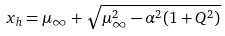<formula> <loc_0><loc_0><loc_500><loc_500>x _ { h } = \mu _ { \infty } + \sqrt { \mu _ { \infty } ^ { 2 } - \alpha ^ { 2 } ( 1 + Q ^ { 2 } ) }</formula> 